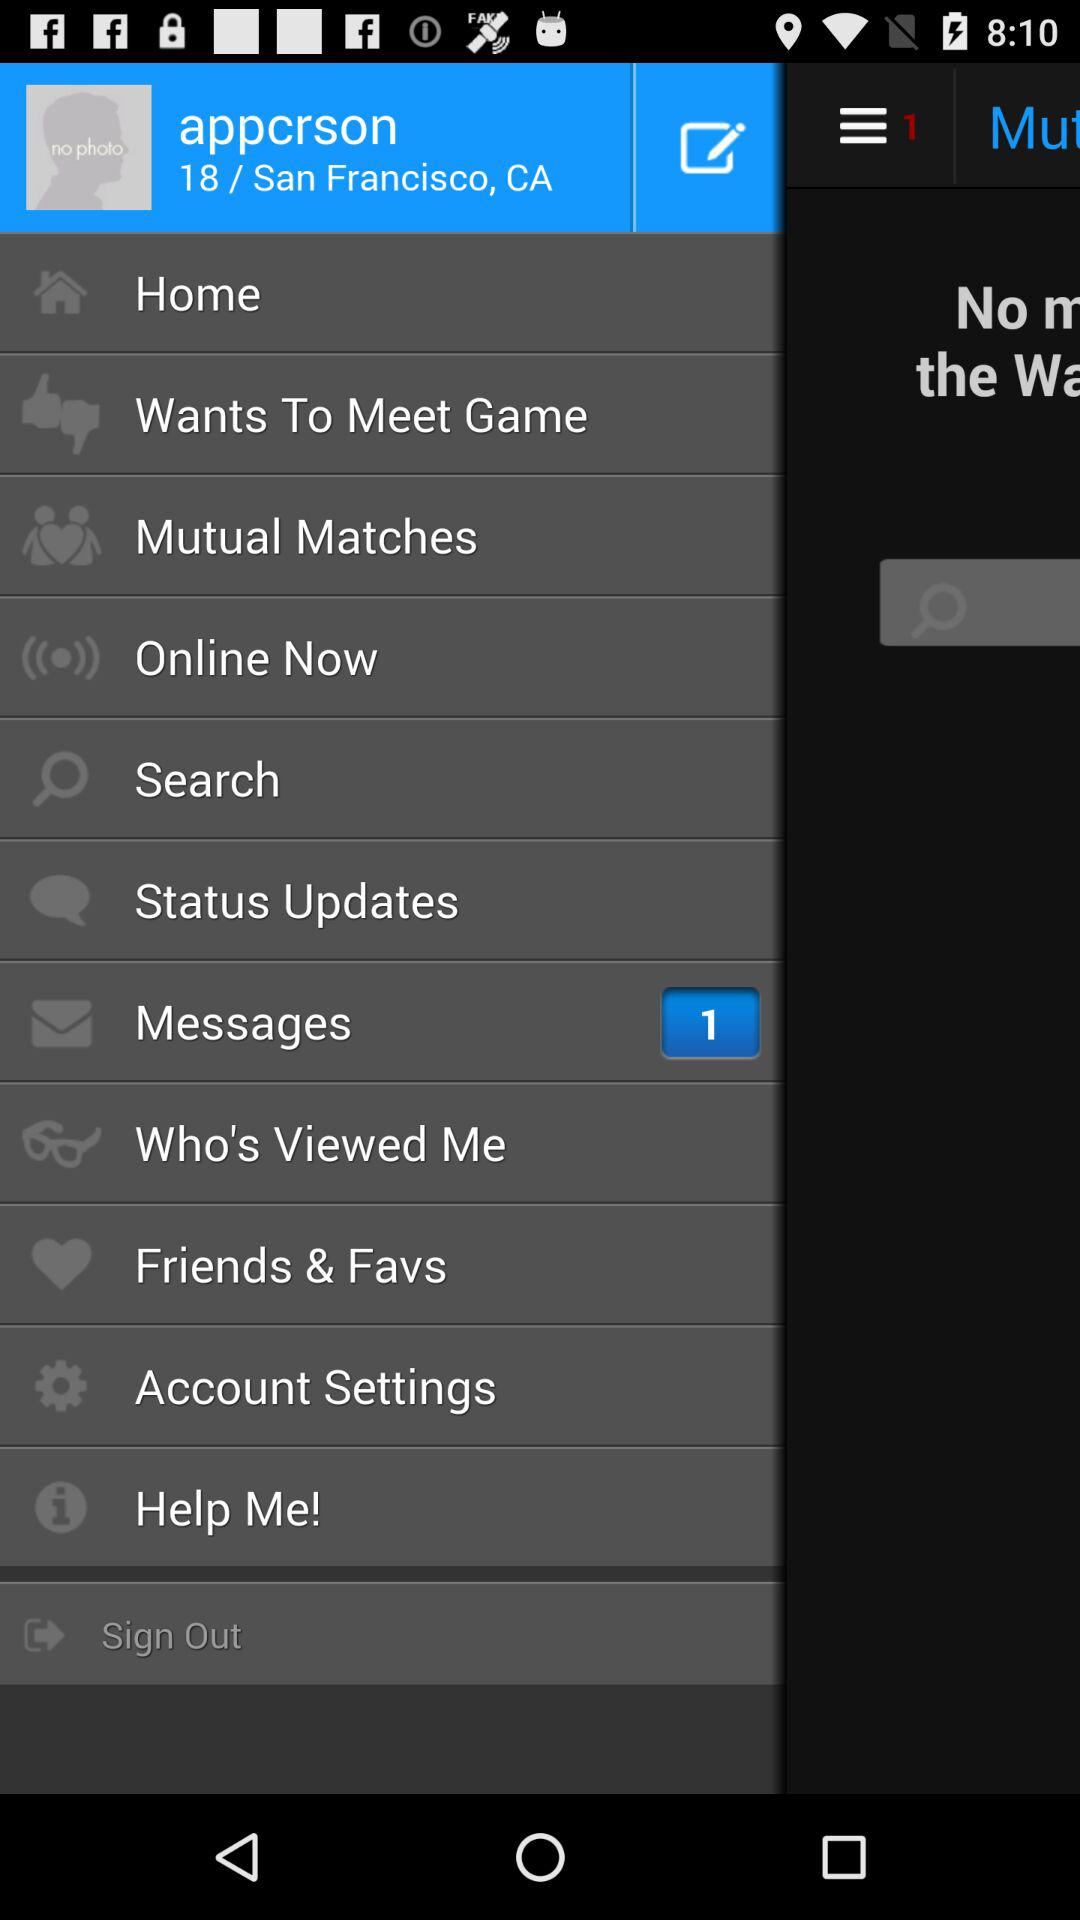What is the username? The username is "appcrson". 